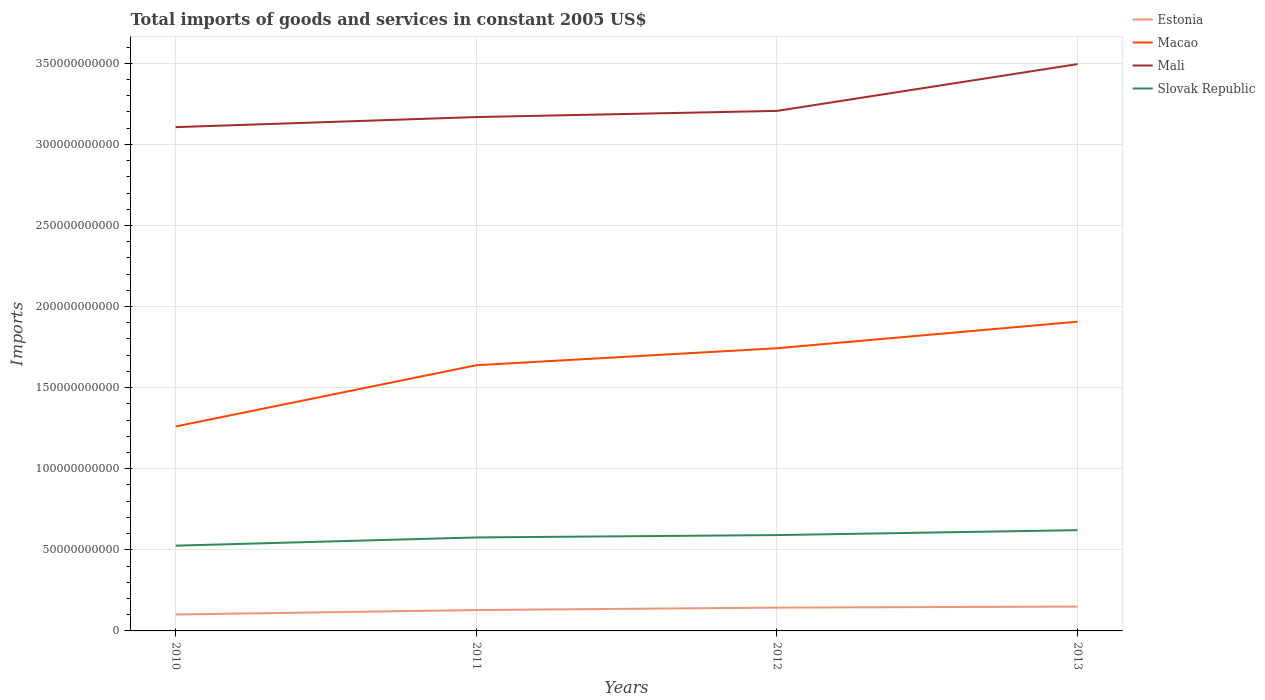How many different coloured lines are there?
Your answer should be compact. 4. Is the number of lines equal to the number of legend labels?
Provide a short and direct response. Yes. Across all years, what is the maximum total imports of goods and services in Mali?
Your answer should be very brief. 3.11e+11. What is the total total imports of goods and services in Mali in the graph?
Your answer should be compact. -1.00e+1. What is the difference between the highest and the second highest total imports of goods and services in Macao?
Your answer should be very brief. 6.46e+1. What is the difference between the highest and the lowest total imports of goods and services in Estonia?
Ensure brevity in your answer.  2. What is the title of the graph?
Ensure brevity in your answer.  Total imports of goods and services in constant 2005 US$. Does "East Asia (all income levels)" appear as one of the legend labels in the graph?
Offer a very short reply. No. What is the label or title of the X-axis?
Keep it short and to the point. Years. What is the label or title of the Y-axis?
Make the answer very short. Imports. What is the Imports of Estonia in 2010?
Your answer should be very brief. 1.01e+1. What is the Imports in Macao in 2010?
Make the answer very short. 1.26e+11. What is the Imports of Mali in 2010?
Provide a succinct answer. 3.11e+11. What is the Imports of Slovak Republic in 2010?
Make the answer very short. 5.26e+1. What is the Imports in Estonia in 2011?
Your answer should be very brief. 1.29e+1. What is the Imports in Macao in 2011?
Your answer should be very brief. 1.64e+11. What is the Imports in Mali in 2011?
Offer a very short reply. 3.17e+11. What is the Imports in Slovak Republic in 2011?
Make the answer very short. 5.76e+1. What is the Imports in Estonia in 2012?
Your response must be concise. 1.44e+1. What is the Imports of Macao in 2012?
Your response must be concise. 1.74e+11. What is the Imports in Mali in 2012?
Provide a short and direct response. 3.21e+11. What is the Imports in Slovak Republic in 2012?
Offer a very short reply. 5.91e+1. What is the Imports in Estonia in 2013?
Ensure brevity in your answer.  1.50e+1. What is the Imports of Macao in 2013?
Your answer should be compact. 1.91e+11. What is the Imports of Mali in 2013?
Your answer should be very brief. 3.49e+11. What is the Imports of Slovak Republic in 2013?
Give a very brief answer. 6.21e+1. Across all years, what is the maximum Imports in Estonia?
Provide a short and direct response. 1.50e+1. Across all years, what is the maximum Imports in Macao?
Make the answer very short. 1.91e+11. Across all years, what is the maximum Imports of Mali?
Give a very brief answer. 3.49e+11. Across all years, what is the maximum Imports of Slovak Republic?
Keep it short and to the point. 6.21e+1. Across all years, what is the minimum Imports in Estonia?
Offer a terse response. 1.01e+1. Across all years, what is the minimum Imports of Macao?
Keep it short and to the point. 1.26e+11. Across all years, what is the minimum Imports of Mali?
Offer a very short reply. 3.11e+11. Across all years, what is the minimum Imports in Slovak Republic?
Your answer should be very brief. 5.26e+1. What is the total Imports in Estonia in the graph?
Offer a very short reply. 5.24e+1. What is the total Imports in Macao in the graph?
Offer a very short reply. 6.55e+11. What is the total Imports in Mali in the graph?
Keep it short and to the point. 1.30e+12. What is the total Imports of Slovak Republic in the graph?
Offer a terse response. 2.31e+11. What is the difference between the Imports in Estonia in 2010 and that in 2011?
Offer a very short reply. -2.75e+09. What is the difference between the Imports of Macao in 2010 and that in 2011?
Your answer should be very brief. -3.78e+1. What is the difference between the Imports of Mali in 2010 and that in 2011?
Make the answer very short. -6.21e+09. What is the difference between the Imports in Slovak Republic in 2010 and that in 2011?
Your answer should be compact. -5.07e+09. What is the difference between the Imports of Estonia in 2010 and that in 2012?
Ensure brevity in your answer.  -4.26e+09. What is the difference between the Imports of Macao in 2010 and that in 2012?
Keep it short and to the point. -4.82e+1. What is the difference between the Imports in Mali in 2010 and that in 2012?
Provide a short and direct response. -1.00e+1. What is the difference between the Imports of Slovak Republic in 2010 and that in 2012?
Your response must be concise. -6.53e+09. What is the difference between the Imports of Estonia in 2010 and that in 2013?
Your response must be concise. -4.90e+09. What is the difference between the Imports in Macao in 2010 and that in 2013?
Your answer should be very brief. -6.46e+1. What is the difference between the Imports of Mali in 2010 and that in 2013?
Make the answer very short. -3.89e+1. What is the difference between the Imports of Slovak Republic in 2010 and that in 2013?
Provide a short and direct response. -9.57e+09. What is the difference between the Imports in Estonia in 2011 and that in 2012?
Ensure brevity in your answer.  -1.50e+09. What is the difference between the Imports in Macao in 2011 and that in 2012?
Your answer should be compact. -1.05e+1. What is the difference between the Imports of Mali in 2011 and that in 2012?
Offer a very short reply. -3.80e+09. What is the difference between the Imports of Slovak Republic in 2011 and that in 2012?
Provide a succinct answer. -1.46e+09. What is the difference between the Imports of Estonia in 2011 and that in 2013?
Your answer should be very brief. -2.15e+09. What is the difference between the Imports of Macao in 2011 and that in 2013?
Give a very brief answer. -2.69e+1. What is the difference between the Imports of Mali in 2011 and that in 2013?
Give a very brief answer. -3.27e+1. What is the difference between the Imports of Slovak Republic in 2011 and that in 2013?
Keep it short and to the point. -4.50e+09. What is the difference between the Imports of Estonia in 2012 and that in 2013?
Your answer should be very brief. -6.45e+08. What is the difference between the Imports in Macao in 2012 and that in 2013?
Provide a short and direct response. -1.64e+1. What is the difference between the Imports of Mali in 2012 and that in 2013?
Your answer should be very brief. -2.89e+1. What is the difference between the Imports of Slovak Republic in 2012 and that in 2013?
Provide a short and direct response. -3.03e+09. What is the difference between the Imports of Estonia in 2010 and the Imports of Macao in 2011?
Your answer should be compact. -1.54e+11. What is the difference between the Imports of Estonia in 2010 and the Imports of Mali in 2011?
Your answer should be compact. -3.07e+11. What is the difference between the Imports in Estonia in 2010 and the Imports in Slovak Republic in 2011?
Provide a short and direct response. -4.75e+1. What is the difference between the Imports of Macao in 2010 and the Imports of Mali in 2011?
Your answer should be very brief. -1.91e+11. What is the difference between the Imports in Macao in 2010 and the Imports in Slovak Republic in 2011?
Keep it short and to the point. 6.84e+1. What is the difference between the Imports in Mali in 2010 and the Imports in Slovak Republic in 2011?
Offer a very short reply. 2.53e+11. What is the difference between the Imports in Estonia in 2010 and the Imports in Macao in 2012?
Ensure brevity in your answer.  -1.64e+11. What is the difference between the Imports of Estonia in 2010 and the Imports of Mali in 2012?
Provide a short and direct response. -3.11e+11. What is the difference between the Imports in Estonia in 2010 and the Imports in Slovak Republic in 2012?
Your answer should be compact. -4.90e+1. What is the difference between the Imports of Macao in 2010 and the Imports of Mali in 2012?
Your answer should be very brief. -1.95e+11. What is the difference between the Imports in Macao in 2010 and the Imports in Slovak Republic in 2012?
Keep it short and to the point. 6.70e+1. What is the difference between the Imports of Mali in 2010 and the Imports of Slovak Republic in 2012?
Give a very brief answer. 2.52e+11. What is the difference between the Imports in Estonia in 2010 and the Imports in Macao in 2013?
Your answer should be compact. -1.81e+11. What is the difference between the Imports of Estonia in 2010 and the Imports of Mali in 2013?
Give a very brief answer. -3.39e+11. What is the difference between the Imports of Estonia in 2010 and the Imports of Slovak Republic in 2013?
Keep it short and to the point. -5.20e+1. What is the difference between the Imports in Macao in 2010 and the Imports in Mali in 2013?
Provide a short and direct response. -2.23e+11. What is the difference between the Imports in Macao in 2010 and the Imports in Slovak Republic in 2013?
Offer a terse response. 6.39e+1. What is the difference between the Imports of Mali in 2010 and the Imports of Slovak Republic in 2013?
Give a very brief answer. 2.48e+11. What is the difference between the Imports of Estonia in 2011 and the Imports of Macao in 2012?
Provide a succinct answer. -1.61e+11. What is the difference between the Imports in Estonia in 2011 and the Imports in Mali in 2012?
Ensure brevity in your answer.  -3.08e+11. What is the difference between the Imports of Estonia in 2011 and the Imports of Slovak Republic in 2012?
Your answer should be very brief. -4.62e+1. What is the difference between the Imports in Macao in 2011 and the Imports in Mali in 2012?
Offer a very short reply. -1.57e+11. What is the difference between the Imports of Macao in 2011 and the Imports of Slovak Republic in 2012?
Provide a short and direct response. 1.05e+11. What is the difference between the Imports in Mali in 2011 and the Imports in Slovak Republic in 2012?
Make the answer very short. 2.58e+11. What is the difference between the Imports in Estonia in 2011 and the Imports in Macao in 2013?
Your response must be concise. -1.78e+11. What is the difference between the Imports of Estonia in 2011 and the Imports of Mali in 2013?
Provide a succinct answer. -3.37e+11. What is the difference between the Imports in Estonia in 2011 and the Imports in Slovak Republic in 2013?
Provide a succinct answer. -4.93e+1. What is the difference between the Imports in Macao in 2011 and the Imports in Mali in 2013?
Keep it short and to the point. -1.86e+11. What is the difference between the Imports in Macao in 2011 and the Imports in Slovak Republic in 2013?
Your answer should be very brief. 1.02e+11. What is the difference between the Imports of Mali in 2011 and the Imports of Slovak Republic in 2013?
Give a very brief answer. 2.55e+11. What is the difference between the Imports of Estonia in 2012 and the Imports of Macao in 2013?
Your answer should be very brief. -1.76e+11. What is the difference between the Imports in Estonia in 2012 and the Imports in Mali in 2013?
Ensure brevity in your answer.  -3.35e+11. What is the difference between the Imports in Estonia in 2012 and the Imports in Slovak Republic in 2013?
Offer a terse response. -4.78e+1. What is the difference between the Imports of Macao in 2012 and the Imports of Mali in 2013?
Your answer should be compact. -1.75e+11. What is the difference between the Imports in Macao in 2012 and the Imports in Slovak Republic in 2013?
Your response must be concise. 1.12e+11. What is the difference between the Imports of Mali in 2012 and the Imports of Slovak Republic in 2013?
Offer a terse response. 2.59e+11. What is the average Imports in Estonia per year?
Your answer should be very brief. 1.31e+1. What is the average Imports in Macao per year?
Offer a very short reply. 1.64e+11. What is the average Imports of Mali per year?
Keep it short and to the point. 3.24e+11. What is the average Imports of Slovak Republic per year?
Your answer should be very brief. 5.79e+1. In the year 2010, what is the difference between the Imports of Estonia and Imports of Macao?
Provide a succinct answer. -1.16e+11. In the year 2010, what is the difference between the Imports in Estonia and Imports in Mali?
Offer a very short reply. -3.01e+11. In the year 2010, what is the difference between the Imports in Estonia and Imports in Slovak Republic?
Provide a succinct answer. -4.25e+1. In the year 2010, what is the difference between the Imports in Macao and Imports in Mali?
Offer a terse response. -1.85e+11. In the year 2010, what is the difference between the Imports of Macao and Imports of Slovak Republic?
Offer a very short reply. 7.35e+1. In the year 2010, what is the difference between the Imports in Mali and Imports in Slovak Republic?
Your response must be concise. 2.58e+11. In the year 2011, what is the difference between the Imports in Estonia and Imports in Macao?
Provide a succinct answer. -1.51e+11. In the year 2011, what is the difference between the Imports of Estonia and Imports of Mali?
Provide a short and direct response. -3.04e+11. In the year 2011, what is the difference between the Imports in Estonia and Imports in Slovak Republic?
Keep it short and to the point. -4.48e+1. In the year 2011, what is the difference between the Imports of Macao and Imports of Mali?
Your answer should be very brief. -1.53e+11. In the year 2011, what is the difference between the Imports of Macao and Imports of Slovak Republic?
Give a very brief answer. 1.06e+11. In the year 2011, what is the difference between the Imports in Mali and Imports in Slovak Republic?
Give a very brief answer. 2.59e+11. In the year 2012, what is the difference between the Imports of Estonia and Imports of Macao?
Keep it short and to the point. -1.60e+11. In the year 2012, what is the difference between the Imports of Estonia and Imports of Mali?
Make the answer very short. -3.06e+11. In the year 2012, what is the difference between the Imports of Estonia and Imports of Slovak Republic?
Keep it short and to the point. -4.47e+1. In the year 2012, what is the difference between the Imports of Macao and Imports of Mali?
Offer a terse response. -1.46e+11. In the year 2012, what is the difference between the Imports of Macao and Imports of Slovak Republic?
Make the answer very short. 1.15e+11. In the year 2012, what is the difference between the Imports in Mali and Imports in Slovak Republic?
Your response must be concise. 2.62e+11. In the year 2013, what is the difference between the Imports in Estonia and Imports in Macao?
Provide a succinct answer. -1.76e+11. In the year 2013, what is the difference between the Imports of Estonia and Imports of Mali?
Provide a succinct answer. -3.34e+11. In the year 2013, what is the difference between the Imports of Estonia and Imports of Slovak Republic?
Keep it short and to the point. -4.71e+1. In the year 2013, what is the difference between the Imports of Macao and Imports of Mali?
Your answer should be compact. -1.59e+11. In the year 2013, what is the difference between the Imports of Macao and Imports of Slovak Republic?
Ensure brevity in your answer.  1.29e+11. In the year 2013, what is the difference between the Imports of Mali and Imports of Slovak Republic?
Provide a short and direct response. 2.87e+11. What is the ratio of the Imports of Estonia in 2010 to that in 2011?
Provide a succinct answer. 0.79. What is the ratio of the Imports in Macao in 2010 to that in 2011?
Provide a short and direct response. 0.77. What is the ratio of the Imports in Mali in 2010 to that in 2011?
Your answer should be very brief. 0.98. What is the ratio of the Imports of Slovak Republic in 2010 to that in 2011?
Give a very brief answer. 0.91. What is the ratio of the Imports of Estonia in 2010 to that in 2012?
Keep it short and to the point. 0.7. What is the ratio of the Imports of Macao in 2010 to that in 2012?
Give a very brief answer. 0.72. What is the ratio of the Imports of Mali in 2010 to that in 2012?
Keep it short and to the point. 0.97. What is the ratio of the Imports of Slovak Republic in 2010 to that in 2012?
Your answer should be very brief. 0.89. What is the ratio of the Imports of Estonia in 2010 to that in 2013?
Your answer should be compact. 0.67. What is the ratio of the Imports of Macao in 2010 to that in 2013?
Provide a succinct answer. 0.66. What is the ratio of the Imports in Mali in 2010 to that in 2013?
Provide a succinct answer. 0.89. What is the ratio of the Imports in Slovak Republic in 2010 to that in 2013?
Provide a succinct answer. 0.85. What is the ratio of the Imports of Estonia in 2011 to that in 2012?
Keep it short and to the point. 0.9. What is the ratio of the Imports in Macao in 2011 to that in 2012?
Your answer should be very brief. 0.94. What is the ratio of the Imports in Slovak Republic in 2011 to that in 2012?
Your answer should be compact. 0.98. What is the ratio of the Imports of Estonia in 2011 to that in 2013?
Make the answer very short. 0.86. What is the ratio of the Imports in Macao in 2011 to that in 2013?
Offer a terse response. 0.86. What is the ratio of the Imports in Mali in 2011 to that in 2013?
Offer a terse response. 0.91. What is the ratio of the Imports of Slovak Republic in 2011 to that in 2013?
Your answer should be very brief. 0.93. What is the ratio of the Imports of Estonia in 2012 to that in 2013?
Ensure brevity in your answer.  0.96. What is the ratio of the Imports in Macao in 2012 to that in 2013?
Your answer should be compact. 0.91. What is the ratio of the Imports of Mali in 2012 to that in 2013?
Offer a very short reply. 0.92. What is the ratio of the Imports in Slovak Republic in 2012 to that in 2013?
Give a very brief answer. 0.95. What is the difference between the highest and the second highest Imports of Estonia?
Ensure brevity in your answer.  6.45e+08. What is the difference between the highest and the second highest Imports in Macao?
Make the answer very short. 1.64e+1. What is the difference between the highest and the second highest Imports of Mali?
Ensure brevity in your answer.  2.89e+1. What is the difference between the highest and the second highest Imports of Slovak Republic?
Your answer should be very brief. 3.03e+09. What is the difference between the highest and the lowest Imports of Estonia?
Offer a very short reply. 4.90e+09. What is the difference between the highest and the lowest Imports of Macao?
Make the answer very short. 6.46e+1. What is the difference between the highest and the lowest Imports of Mali?
Offer a very short reply. 3.89e+1. What is the difference between the highest and the lowest Imports of Slovak Republic?
Make the answer very short. 9.57e+09. 